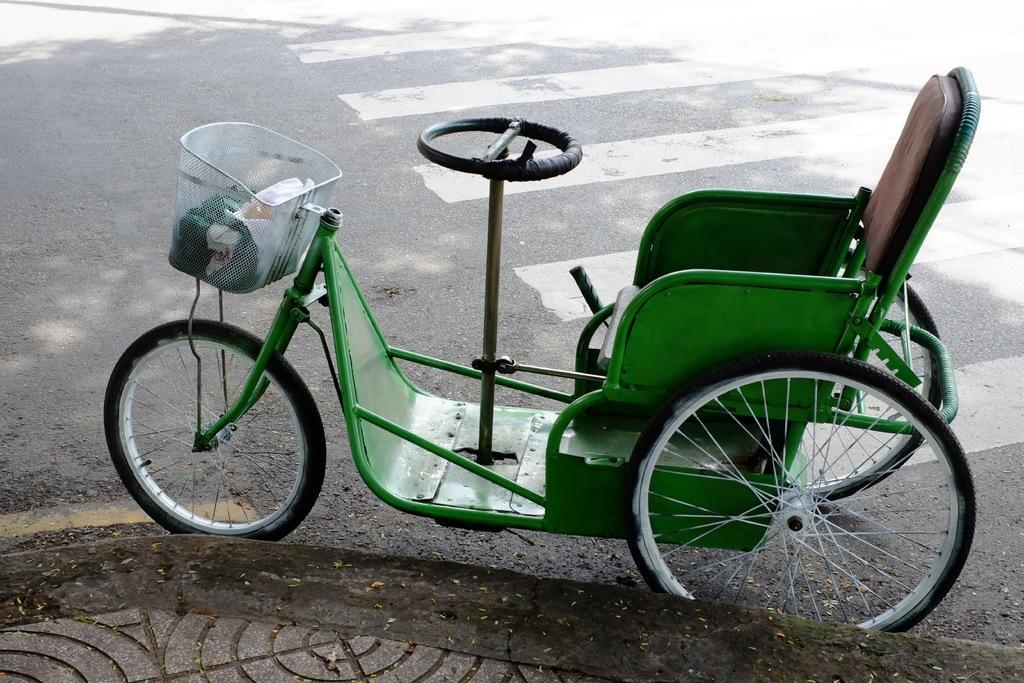What type of vehicle is in the image? There is a tricycle in the image. What color is the tricycle? The tricycle is green in color. Where is the tricycle located? The tricycle is on the road. How many apples are hanging from the handlebars of the tricycle in the image? There are no apples present in the image, and therefore no apples can be seen hanging from the handlebars. 